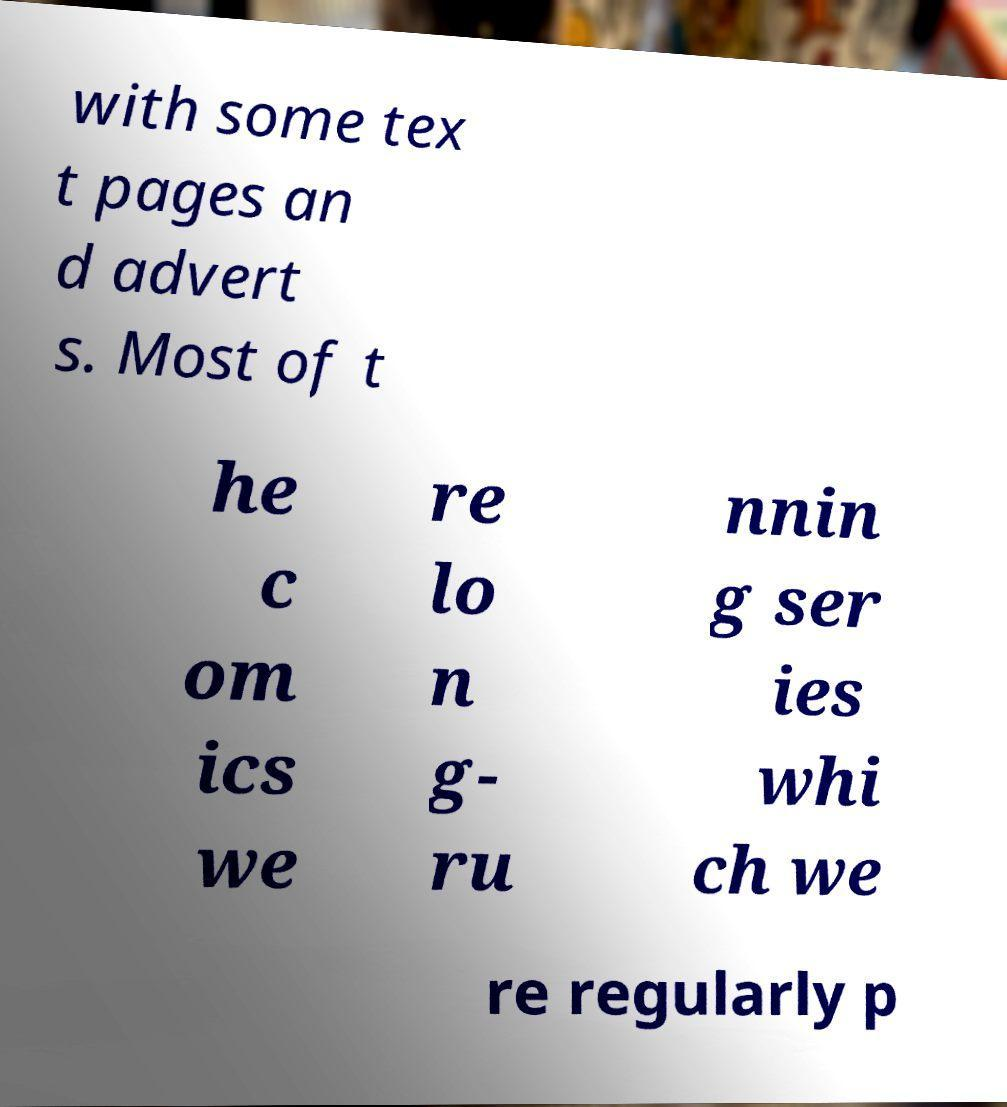Can you read and provide the text displayed in the image?This photo seems to have some interesting text. Can you extract and type it out for me? with some tex t pages an d advert s. Most of t he c om ics we re lo n g- ru nnin g ser ies whi ch we re regularly p 